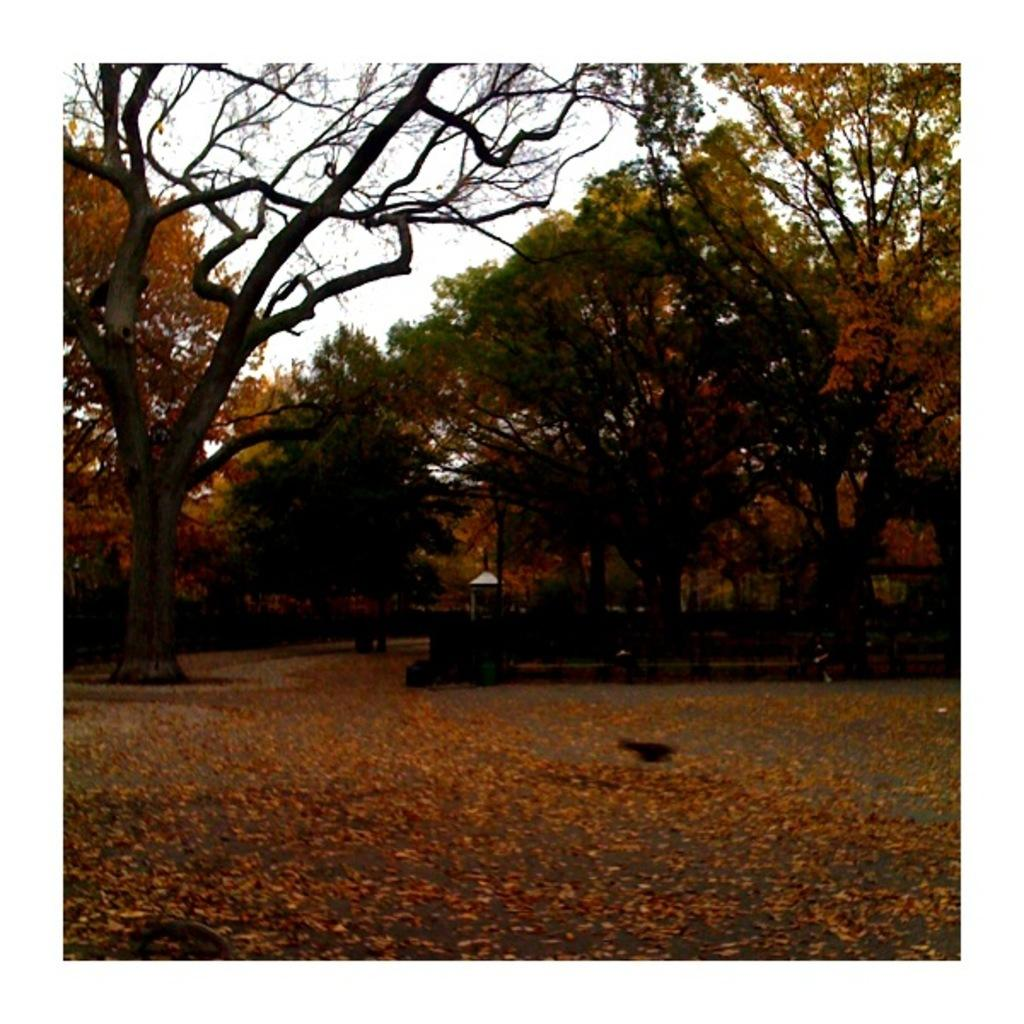What type of vegetation can be seen in the image? There are trees in the image. Can you see a frog kissing a prince in the image? There is no frog or prince present in the image, and therefore no such activity can be observed. 